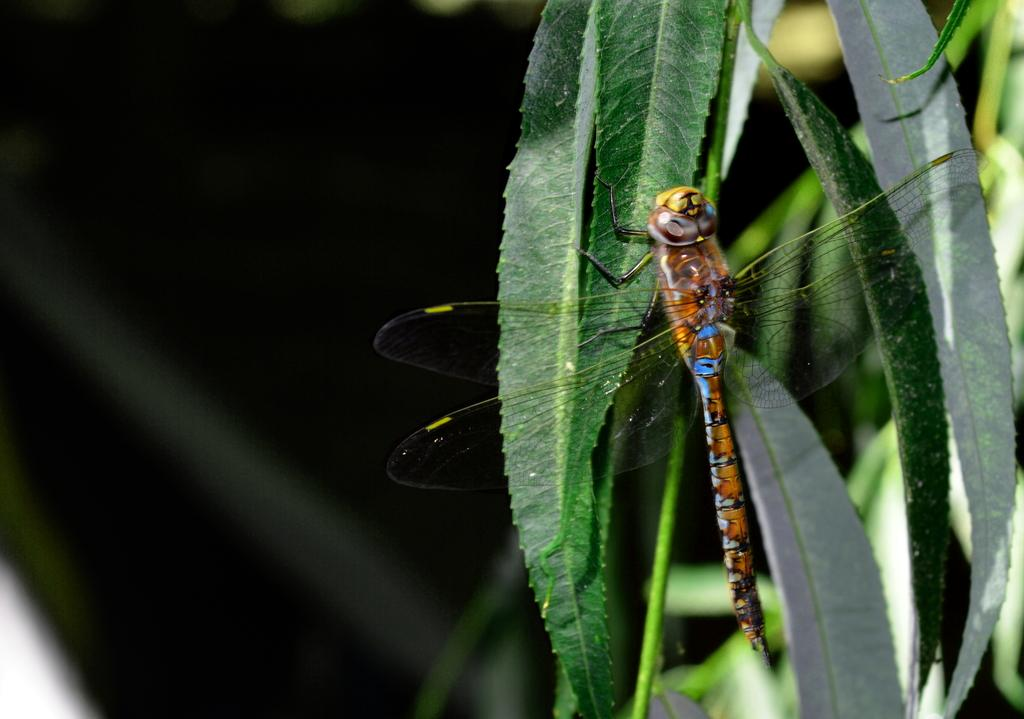What insect is present in the image? There is a dragonfly in the image. Where is the dragonfly located? The dragonfly is on a leaf. What is the leaf a part of? The leaf is part of a plant. How would you describe the background of the image? The background of the image is blurred. How many sisters does the dragonfly have in the image? There are no sisters mentioned or depicted in the image, as it features a dragonfly on a leaf. 